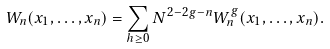<formula> <loc_0><loc_0><loc_500><loc_500>W _ { n } ( x _ { 1 } , \dots , x _ { n } ) = \sum _ { h \geq 0 } N ^ { 2 - 2 g - n } W _ { n } ^ { g } ( x _ { 1 } , \dots , x _ { n } ) .</formula> 